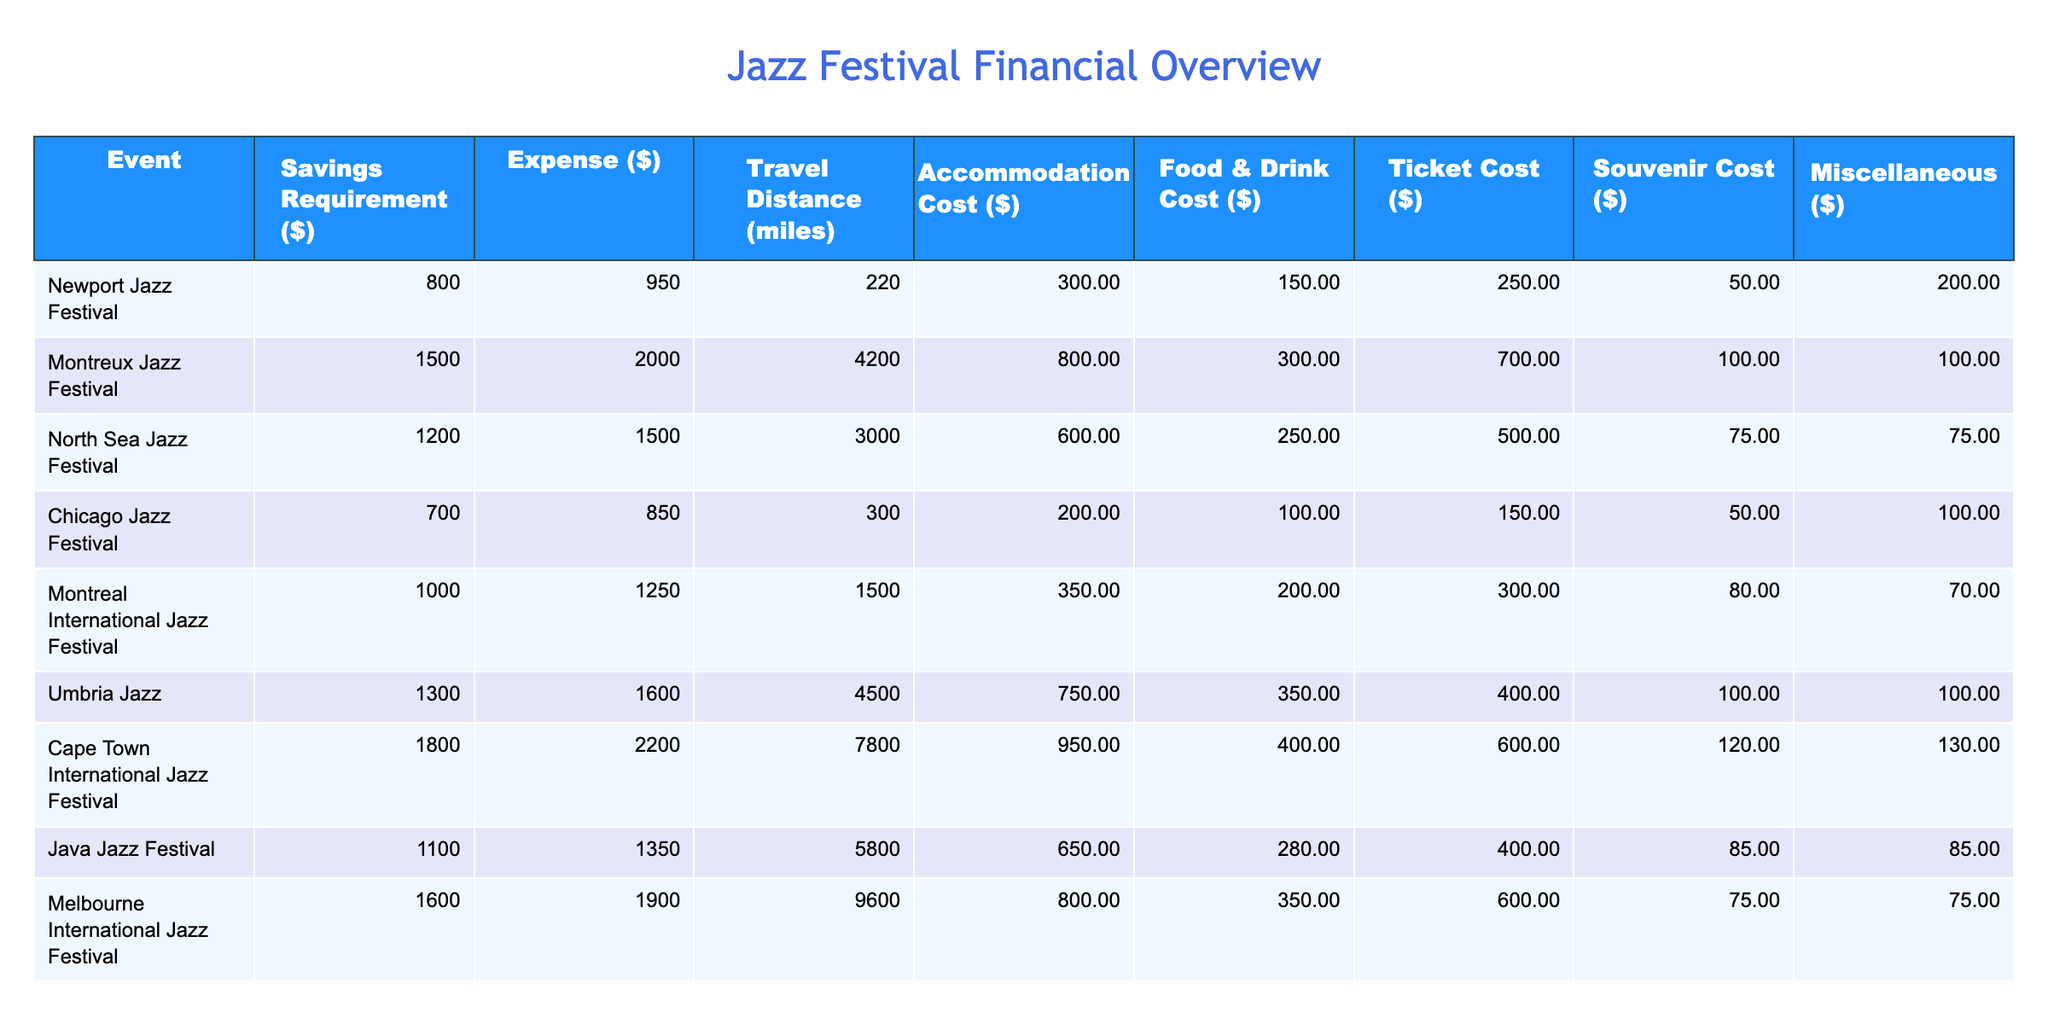What is the total expense for attending the Cape Town International Jazz Festival? The expense for attending the Cape Town International Jazz Festival is listed as $2200, which is the value found in the Expense column for this event.
Answer: 2200 What is the travel distance to Montreal International Jazz Festival? The travel distance to the Montreal International Jazz Festival is shown as 1500 miles, which is directly indicated in the Travel Distance column for this event.
Answer: 1500 miles Which jazz festival requires the highest savings requirement? The Cape Town International Jazz Festival has the highest savings requirement, listed as $1800, placing it at the top of the Savings Requirement column.
Answer: 1800 What is the average food and drink cost for these festivals? To find the average food and drink cost, sum all values in the Food & Drink Cost column: 150 + 300 + 250 + 100 + 200 + 350 + 400 + 280 + 350 = 2080. There are 9 festivals, so the average is 2080 / 9 = approximately 231.11.
Answer: 231.11 Is the ticket cost for the Newport Jazz Festival less than $300? The ticket cost for the Newport Jazz Festival is listed as $250, which is less than $300, confirming that the statement is true.
Answer: Yes What is the difference in accommodation costs between the Montreux Jazz Festival and the Chicago Jazz Festival? The accommodation cost for the Montreux Jazz Festival is $800, while the cost for the Chicago Jazz Festival is $200. The difference is calculated as $800 - $200 = $600.
Answer: 600 What festival has the lowest total expense, including travel, accommodation, food, ticket, souvenir, and miscellaneous costs? To find the lowest total expense, calculate the total for each festival. For Newport, it's 950 + 300 + 150 + 250 + 50 + 200 = 1950. The totals for others will show that the Chicago Jazz Festival has the lowest total of 850 + 200 + 100 + 150 + 50 + 100 = 1550.
Answer: Chicago Jazz Festival Which festival has a savings requirement of less than $1000 and also cost less than $1000 in total expenses? The Chicago Jazz Festival fits this criteria with a savings requirement of $700 and total expenses ($850) being less than $1000.
Answer: Chicago Jazz Festival 